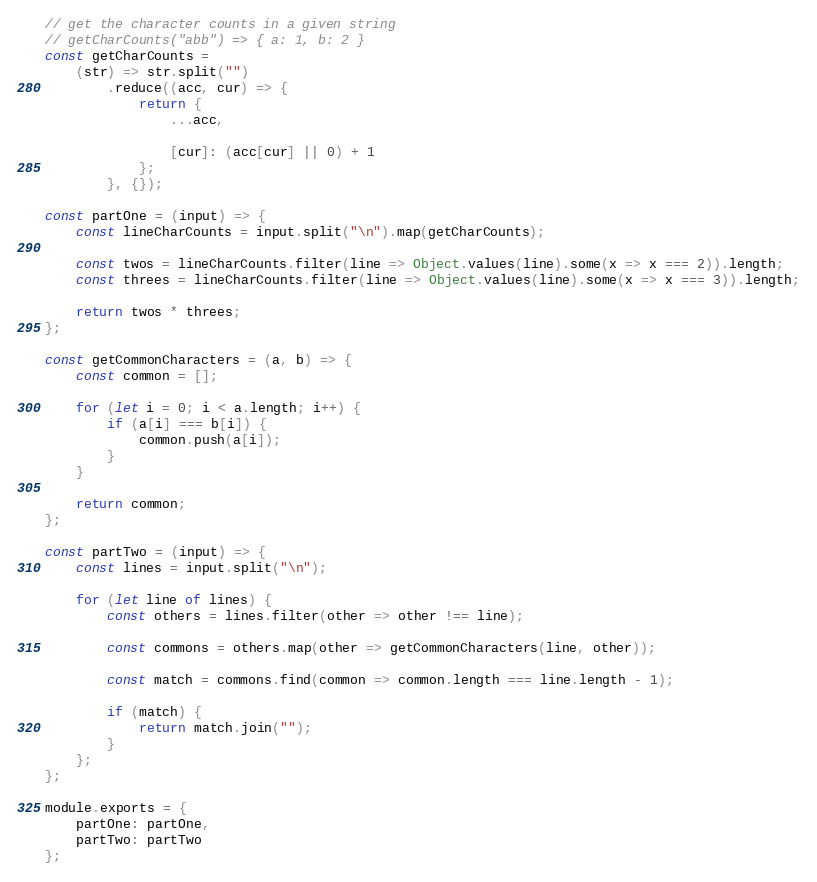<code> <loc_0><loc_0><loc_500><loc_500><_JavaScript_>// get the character counts in a given string
// getCharCounts("abb") => { a: 1, b: 2 }
const getCharCounts = 
    (str) => str.split("")
        .reduce((acc, cur) => {
            return {
                ...acc,

                [cur]: (acc[cur] || 0) + 1
            };
        }, {});

const partOne = (input) => {
    const lineCharCounts = input.split("\n").map(getCharCounts);

    const twos = lineCharCounts.filter(line => Object.values(line).some(x => x === 2)).length;
    const threes = lineCharCounts.filter(line => Object.values(line).some(x => x === 3)).length;

    return twos * threes;
};

const getCommonCharacters = (a, b) => {
    const common = [];

    for (let i = 0; i < a.length; i++) {
        if (a[i] === b[i]) {
            common.push(a[i]);
        }
    }

    return common;
};

const partTwo = (input) => {
    const lines = input.split("\n");

    for (let line of lines) {
        const others = lines.filter(other => other !== line);

        const commons = others.map(other => getCommonCharacters(line, other));

        const match = commons.find(common => common.length === line.length - 1);

        if (match) {
            return match.join("");
        }
    };
};

module.exports = {
    partOne: partOne,
    partTwo: partTwo
};
</code> 